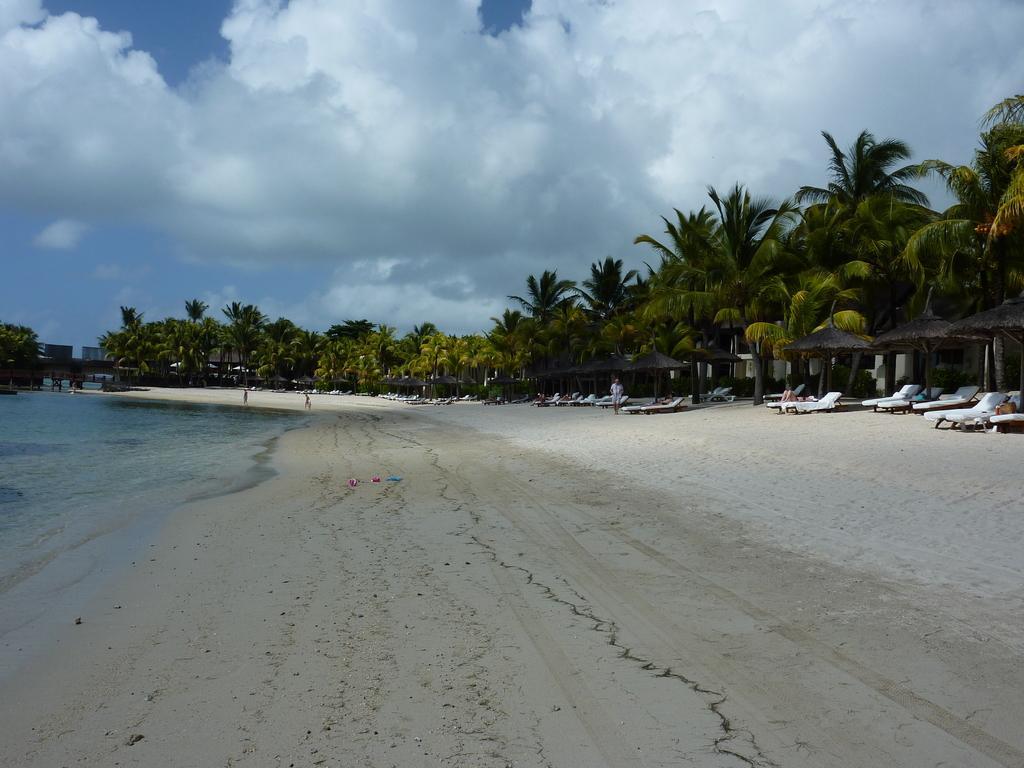Could you give a brief overview of what you see in this image? In this image I can see water on the left side and ground on the right side. I can also see number of chairs and few people on the ground. In the background I can see number of trees, clouds and the sky. 